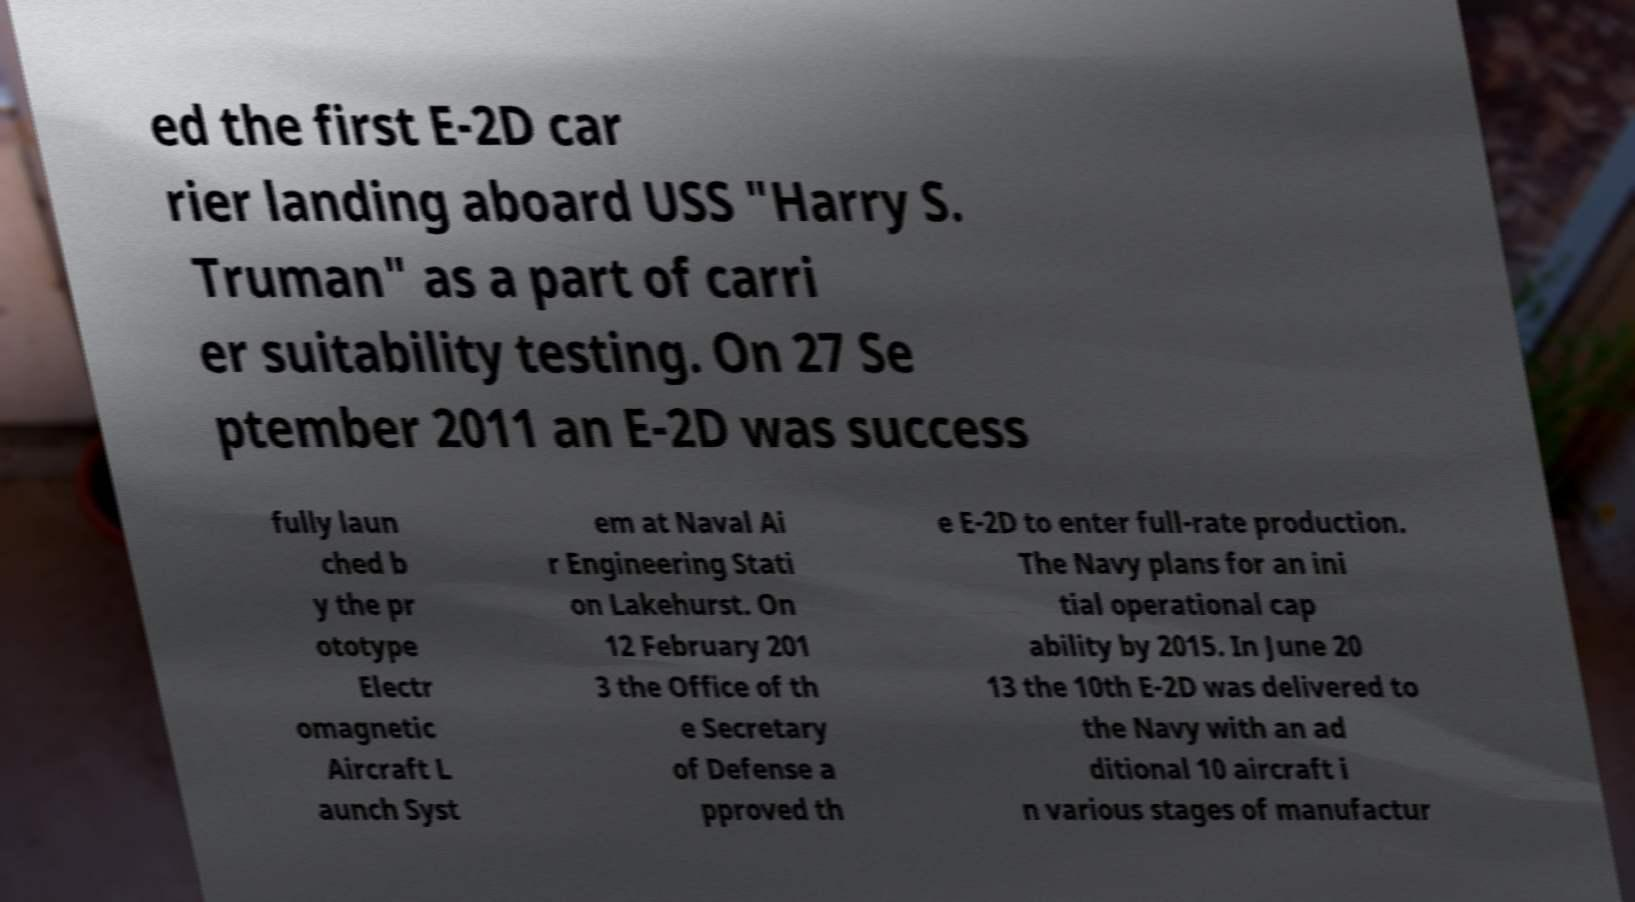Please identify and transcribe the text found in this image. ed the first E-2D car rier landing aboard USS "Harry S. Truman" as a part of carri er suitability testing. On 27 Se ptember 2011 an E-2D was success fully laun ched b y the pr ototype Electr omagnetic Aircraft L aunch Syst em at Naval Ai r Engineering Stati on Lakehurst. On 12 February 201 3 the Office of th e Secretary of Defense a pproved th e E-2D to enter full-rate production. The Navy plans for an ini tial operational cap ability by 2015. In June 20 13 the 10th E-2D was delivered to the Navy with an ad ditional 10 aircraft i n various stages of manufactur 